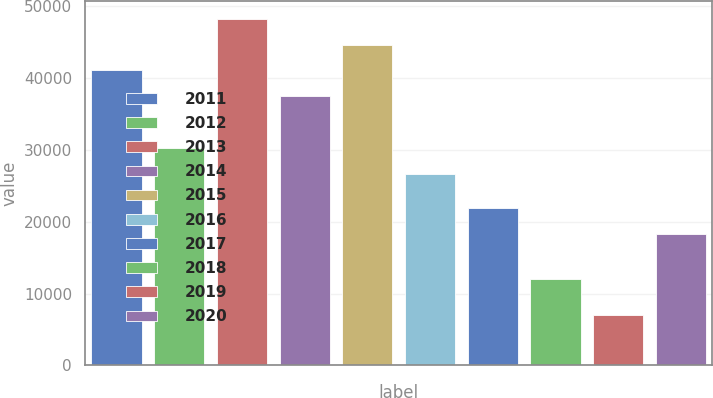Convert chart. <chart><loc_0><loc_0><loc_500><loc_500><bar_chart><fcel>2011<fcel>2012<fcel>2013<fcel>2014<fcel>2015<fcel>2016<fcel>2017<fcel>2018<fcel>2019<fcel>2020<nl><fcel>41060.6<fcel>30271.4<fcel>48253.4<fcel>37464.2<fcel>44657<fcel>26675<fcel>21921.4<fcel>12008<fcel>7067<fcel>18325<nl></chart> 